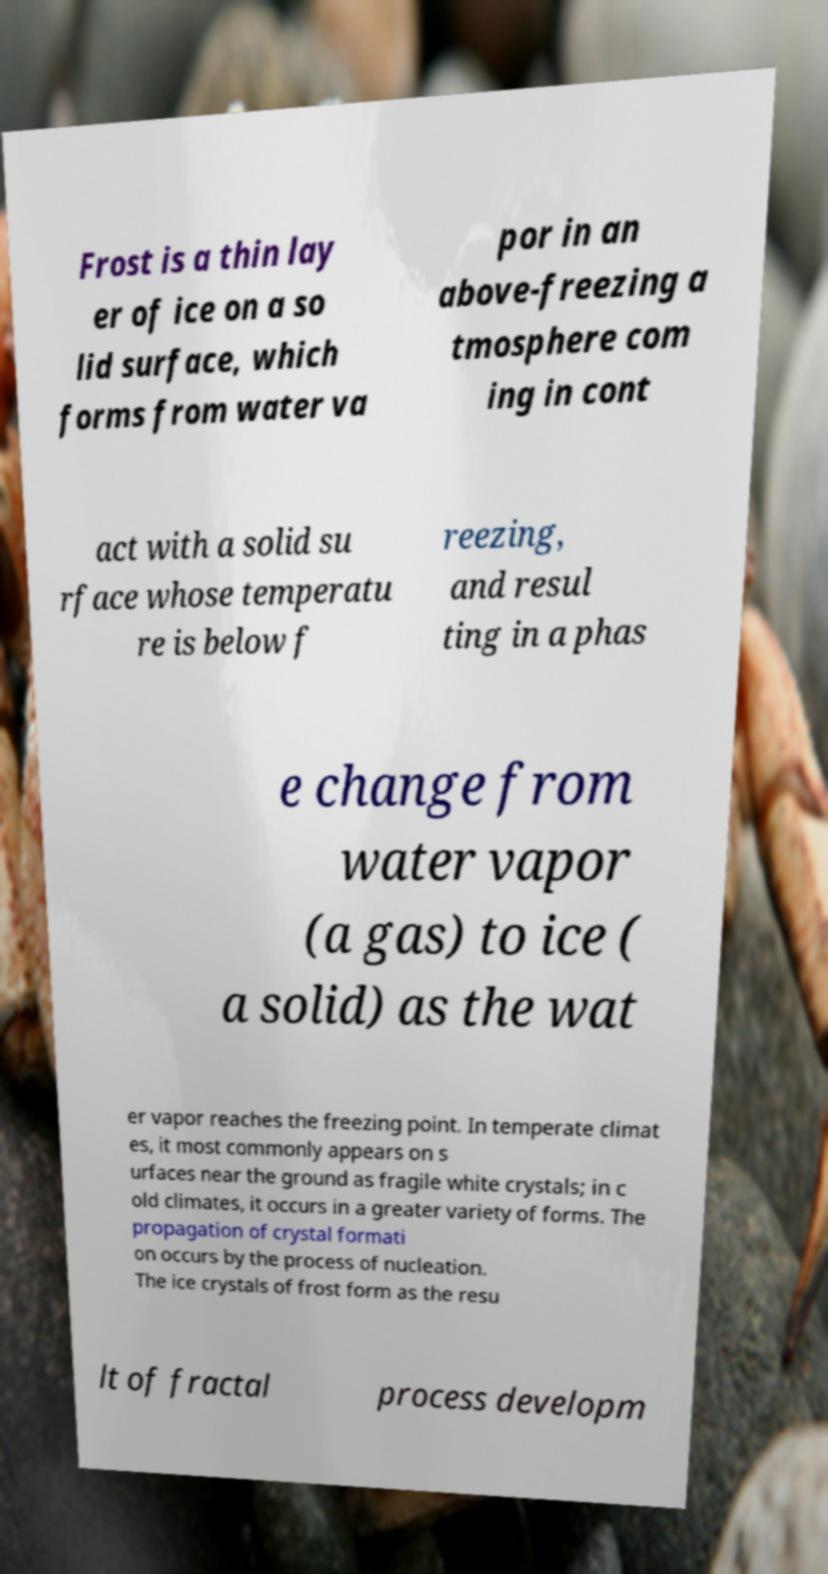Please read and relay the text visible in this image. What does it say? Frost is a thin lay er of ice on a so lid surface, which forms from water va por in an above-freezing a tmosphere com ing in cont act with a solid su rface whose temperatu re is below f reezing, and resul ting in a phas e change from water vapor (a gas) to ice ( a solid) as the wat er vapor reaches the freezing point. In temperate climat es, it most commonly appears on s urfaces near the ground as fragile white crystals; in c old climates, it occurs in a greater variety of forms. The propagation of crystal formati on occurs by the process of nucleation. The ice crystals of frost form as the resu lt of fractal process developm 